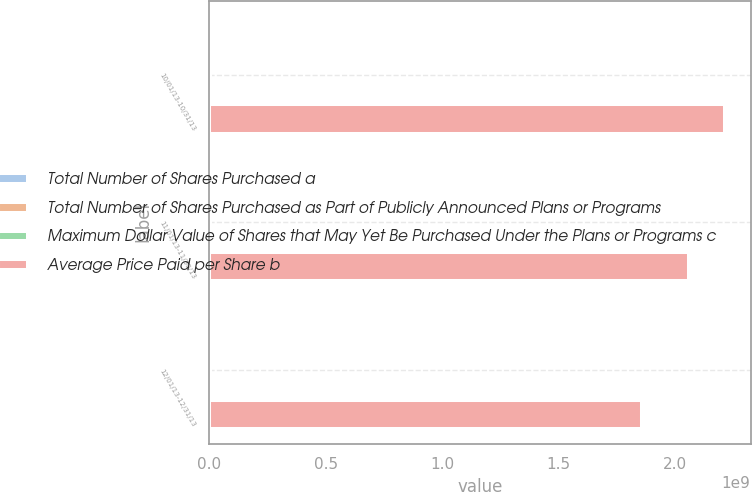<chart> <loc_0><loc_0><loc_500><loc_500><stacked_bar_chart><ecel><fcel>10/01/13-10/31/13<fcel>11/01/13-11/30/13<fcel>12/01/13-12/31/13<nl><fcel>Total Number of Shares Purchased a<fcel>1.46739e+06<fcel>2.06026e+06<fcel>2.35382e+06<nl><fcel>Total Number of Shares Purchased as Part of Publicly Announced Plans or Programs<fcel>64.73<fcel>75.25<fcel>85.81<nl><fcel>Maximum Dollar Value of Shares that May Yet Be Purchased Under the Plans or Programs c<fcel>1.4669e+06<fcel>2.0595e+06<fcel>2.3525e+06<nl><fcel>Average Price Paid per Share b<fcel>2.21386e+09<fcel>2.05888e+09<fcel>1.85702e+09<nl></chart> 